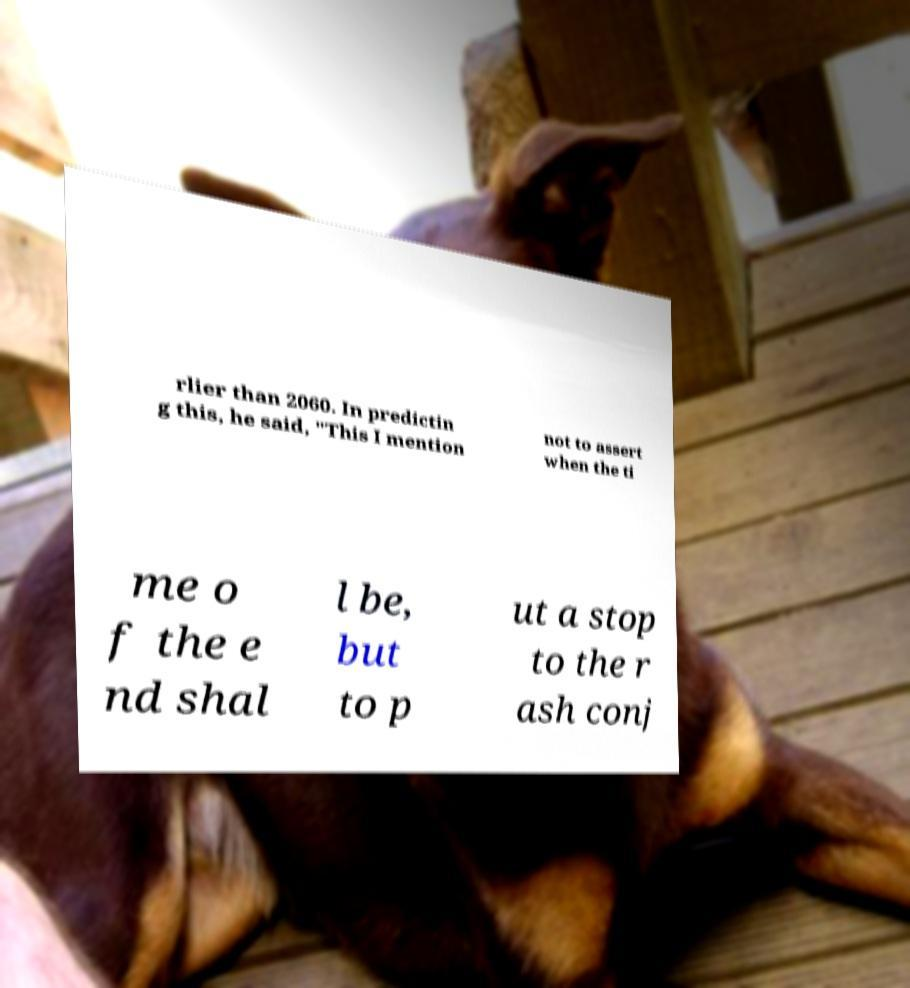Please identify and transcribe the text found in this image. rlier than 2060. In predictin g this, he said, "This I mention not to assert when the ti me o f the e nd shal l be, but to p ut a stop to the r ash conj 